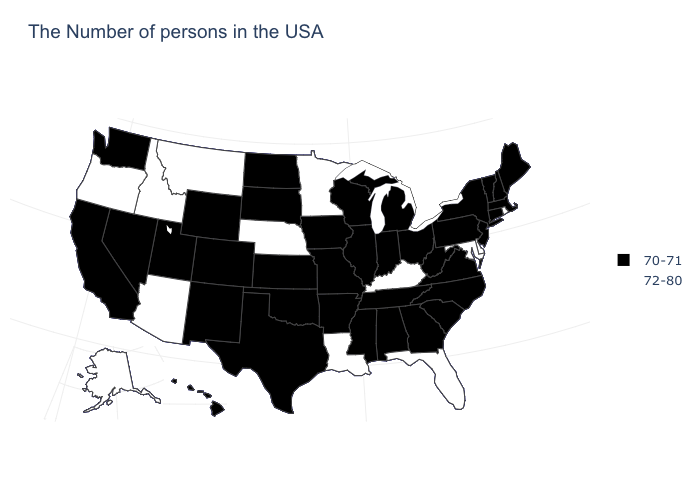Is the legend a continuous bar?
Be succinct. No. Which states hav the highest value in the MidWest?
Keep it brief. Minnesota, Nebraska. Does the first symbol in the legend represent the smallest category?
Short answer required. Yes. Name the states that have a value in the range 72-80?
Give a very brief answer. Rhode Island, Delaware, Maryland, Florida, Kentucky, Louisiana, Minnesota, Nebraska, Montana, Arizona, Idaho, Oregon, Alaska. Does South Dakota have the lowest value in the MidWest?
Give a very brief answer. Yes. Name the states that have a value in the range 72-80?
Concise answer only. Rhode Island, Delaware, Maryland, Florida, Kentucky, Louisiana, Minnesota, Nebraska, Montana, Arizona, Idaho, Oregon, Alaska. What is the value of Missouri?
Concise answer only. 70-71. Is the legend a continuous bar?
Short answer required. No. What is the lowest value in states that border Vermont?
Be succinct. 70-71. What is the highest value in the Northeast ?
Short answer required. 72-80. Which states have the highest value in the USA?
Short answer required. Rhode Island, Delaware, Maryland, Florida, Kentucky, Louisiana, Minnesota, Nebraska, Montana, Arizona, Idaho, Oregon, Alaska. What is the value of Kentucky?
Be succinct. 72-80. What is the lowest value in the USA?
Short answer required. 70-71. Does Virginia have the same value as Pennsylvania?
Be succinct. Yes. Name the states that have a value in the range 70-71?
Answer briefly. Maine, Massachusetts, New Hampshire, Vermont, Connecticut, New York, New Jersey, Pennsylvania, Virginia, North Carolina, South Carolina, West Virginia, Ohio, Georgia, Michigan, Indiana, Alabama, Tennessee, Wisconsin, Illinois, Mississippi, Missouri, Arkansas, Iowa, Kansas, Oklahoma, Texas, South Dakota, North Dakota, Wyoming, Colorado, New Mexico, Utah, Nevada, California, Washington, Hawaii. 